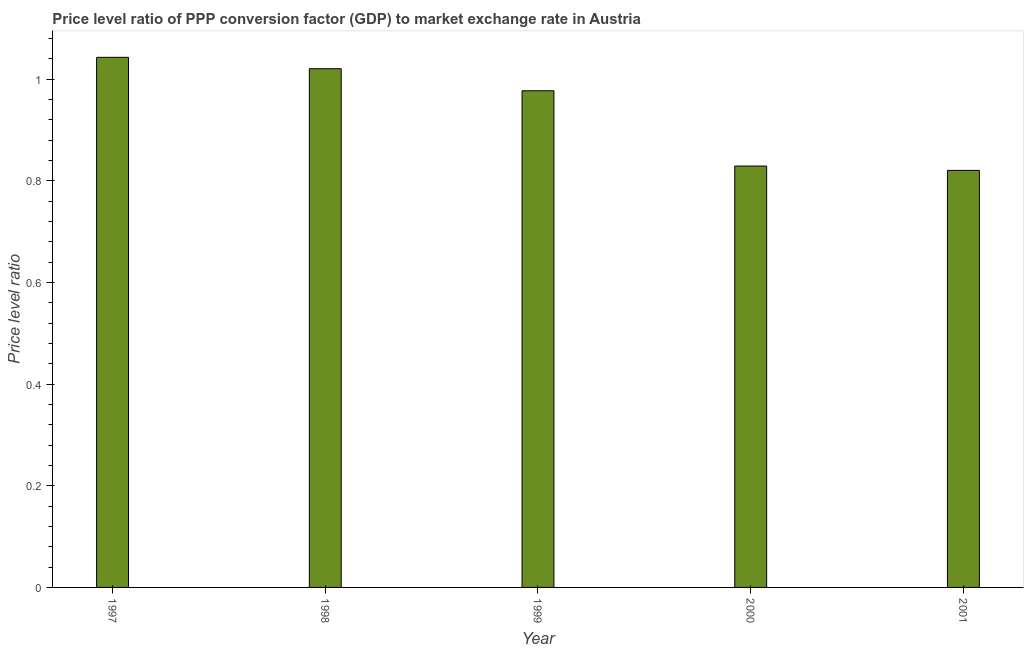What is the title of the graph?
Your response must be concise. Price level ratio of PPP conversion factor (GDP) to market exchange rate in Austria. What is the label or title of the X-axis?
Your answer should be very brief. Year. What is the label or title of the Y-axis?
Make the answer very short. Price level ratio. What is the price level ratio in 1998?
Provide a succinct answer. 1.02. Across all years, what is the maximum price level ratio?
Keep it short and to the point. 1.04. Across all years, what is the minimum price level ratio?
Give a very brief answer. 0.82. In which year was the price level ratio maximum?
Provide a short and direct response. 1997. In which year was the price level ratio minimum?
Make the answer very short. 2001. What is the sum of the price level ratio?
Give a very brief answer. 4.69. What is the difference between the price level ratio in 1998 and 2000?
Provide a short and direct response. 0.19. What is the average price level ratio per year?
Your answer should be compact. 0.94. What is the median price level ratio?
Offer a terse response. 0.98. In how many years, is the price level ratio greater than 0.8 ?
Your answer should be very brief. 5. Is the price level ratio in 1999 less than that in 2000?
Offer a terse response. No. Is the difference between the price level ratio in 1998 and 2000 greater than the difference between any two years?
Give a very brief answer. No. What is the difference between the highest and the second highest price level ratio?
Your answer should be compact. 0.02. Is the sum of the price level ratio in 1999 and 2000 greater than the maximum price level ratio across all years?
Your answer should be compact. Yes. What is the difference between the highest and the lowest price level ratio?
Ensure brevity in your answer.  0.22. How many bars are there?
Your response must be concise. 5. Are all the bars in the graph horizontal?
Your answer should be compact. No. What is the Price level ratio of 1997?
Ensure brevity in your answer.  1.04. What is the Price level ratio of 1998?
Keep it short and to the point. 1.02. What is the Price level ratio of 1999?
Give a very brief answer. 0.98. What is the Price level ratio in 2000?
Your answer should be very brief. 0.83. What is the Price level ratio in 2001?
Ensure brevity in your answer.  0.82. What is the difference between the Price level ratio in 1997 and 1998?
Offer a very short reply. 0.02. What is the difference between the Price level ratio in 1997 and 1999?
Provide a short and direct response. 0.07. What is the difference between the Price level ratio in 1997 and 2000?
Your answer should be compact. 0.21. What is the difference between the Price level ratio in 1997 and 2001?
Provide a succinct answer. 0.22. What is the difference between the Price level ratio in 1998 and 1999?
Offer a terse response. 0.04. What is the difference between the Price level ratio in 1998 and 2000?
Your answer should be compact. 0.19. What is the difference between the Price level ratio in 1998 and 2001?
Provide a succinct answer. 0.2. What is the difference between the Price level ratio in 1999 and 2000?
Provide a succinct answer. 0.15. What is the difference between the Price level ratio in 1999 and 2001?
Provide a succinct answer. 0.16. What is the difference between the Price level ratio in 2000 and 2001?
Give a very brief answer. 0.01. What is the ratio of the Price level ratio in 1997 to that in 1999?
Provide a succinct answer. 1.07. What is the ratio of the Price level ratio in 1997 to that in 2000?
Offer a terse response. 1.26. What is the ratio of the Price level ratio in 1997 to that in 2001?
Provide a short and direct response. 1.27. What is the ratio of the Price level ratio in 1998 to that in 1999?
Offer a terse response. 1.04. What is the ratio of the Price level ratio in 1998 to that in 2000?
Offer a terse response. 1.23. What is the ratio of the Price level ratio in 1998 to that in 2001?
Your answer should be very brief. 1.24. What is the ratio of the Price level ratio in 1999 to that in 2000?
Make the answer very short. 1.18. What is the ratio of the Price level ratio in 1999 to that in 2001?
Your response must be concise. 1.19. 